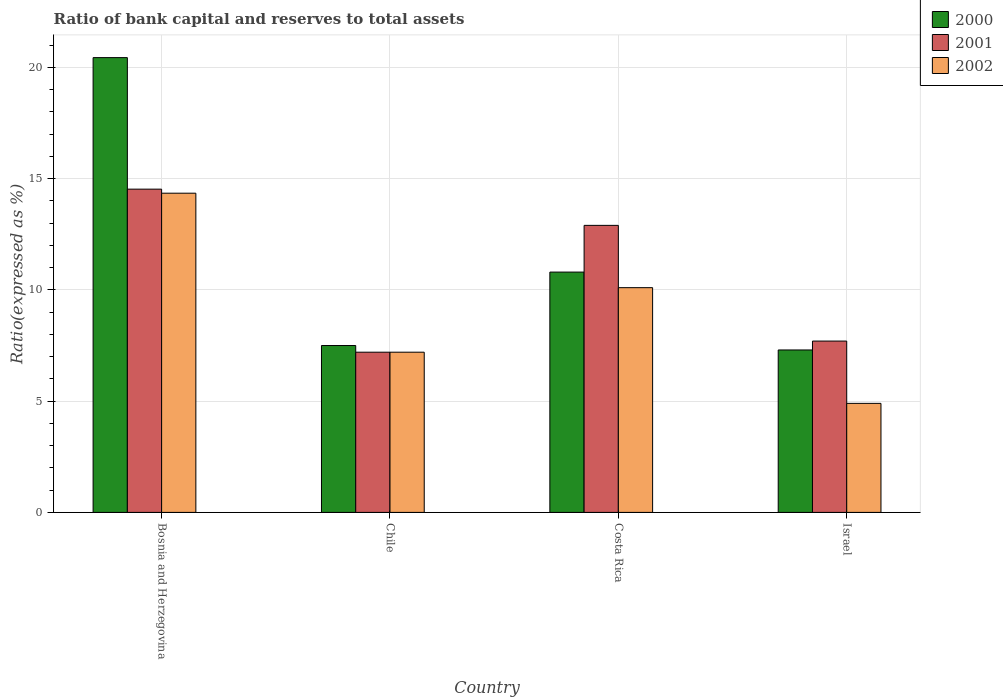How many groups of bars are there?
Offer a very short reply. 4. Are the number of bars per tick equal to the number of legend labels?
Give a very brief answer. Yes. Are the number of bars on each tick of the X-axis equal?
Make the answer very short. Yes. How many bars are there on the 1st tick from the left?
Ensure brevity in your answer.  3. How many bars are there on the 4th tick from the right?
Make the answer very short. 3. What is the label of the 4th group of bars from the left?
Offer a terse response. Israel. Across all countries, what is the maximum ratio of bank capital and reserves to total assets in 2001?
Provide a short and direct response. 14.53. In which country was the ratio of bank capital and reserves to total assets in 2000 maximum?
Your response must be concise. Bosnia and Herzegovina. In which country was the ratio of bank capital and reserves to total assets in 2001 minimum?
Ensure brevity in your answer.  Chile. What is the total ratio of bank capital and reserves to total assets in 2001 in the graph?
Your answer should be compact. 42.33. What is the difference between the ratio of bank capital and reserves to total assets in 2002 in Chile and that in Costa Rica?
Your response must be concise. -2.9. What is the difference between the ratio of bank capital and reserves to total assets in 2000 in Bosnia and Herzegovina and the ratio of bank capital and reserves to total assets in 2001 in Israel?
Give a very brief answer. 12.74. What is the average ratio of bank capital and reserves to total assets in 2000 per country?
Your answer should be compact. 11.51. What is the difference between the ratio of bank capital and reserves to total assets of/in 2002 and ratio of bank capital and reserves to total assets of/in 2001 in Bosnia and Herzegovina?
Your answer should be very brief. -0.18. What is the ratio of the ratio of bank capital and reserves to total assets in 2002 in Bosnia and Herzegovina to that in Israel?
Give a very brief answer. 2.93. Is the ratio of bank capital and reserves to total assets in 2001 in Bosnia and Herzegovina less than that in Costa Rica?
Provide a succinct answer. No. What is the difference between the highest and the second highest ratio of bank capital and reserves to total assets in 2001?
Your answer should be very brief. -1.63. What is the difference between the highest and the lowest ratio of bank capital and reserves to total assets in 2000?
Give a very brief answer. 13.14. What does the 2nd bar from the left in Israel represents?
Keep it short and to the point. 2001. Is it the case that in every country, the sum of the ratio of bank capital and reserves to total assets in 2002 and ratio of bank capital and reserves to total assets in 2000 is greater than the ratio of bank capital and reserves to total assets in 2001?
Offer a terse response. Yes. How many bars are there?
Provide a succinct answer. 12. Are all the bars in the graph horizontal?
Offer a very short reply. No. What is the title of the graph?
Offer a very short reply. Ratio of bank capital and reserves to total assets. What is the label or title of the Y-axis?
Provide a succinct answer. Ratio(expressed as %). What is the Ratio(expressed as %) in 2000 in Bosnia and Herzegovina?
Keep it short and to the point. 20.44. What is the Ratio(expressed as %) of 2001 in Bosnia and Herzegovina?
Your answer should be very brief. 14.53. What is the Ratio(expressed as %) in 2002 in Bosnia and Herzegovina?
Your answer should be very brief. 14.35. What is the Ratio(expressed as %) of 2000 in Chile?
Make the answer very short. 7.5. What is the Ratio(expressed as %) in 2002 in Chile?
Your response must be concise. 7.2. What is the Ratio(expressed as %) of 2000 in Israel?
Offer a very short reply. 7.3. Across all countries, what is the maximum Ratio(expressed as %) in 2000?
Your response must be concise. 20.44. Across all countries, what is the maximum Ratio(expressed as %) of 2001?
Make the answer very short. 14.53. Across all countries, what is the maximum Ratio(expressed as %) in 2002?
Ensure brevity in your answer.  14.35. Across all countries, what is the minimum Ratio(expressed as %) in 2000?
Your answer should be very brief. 7.3. Across all countries, what is the minimum Ratio(expressed as %) of 2001?
Your answer should be compact. 7.2. What is the total Ratio(expressed as %) in 2000 in the graph?
Your answer should be compact. 46.04. What is the total Ratio(expressed as %) in 2001 in the graph?
Provide a short and direct response. 42.33. What is the total Ratio(expressed as %) in 2002 in the graph?
Ensure brevity in your answer.  36.55. What is the difference between the Ratio(expressed as %) in 2000 in Bosnia and Herzegovina and that in Chile?
Keep it short and to the point. 12.94. What is the difference between the Ratio(expressed as %) of 2001 in Bosnia and Herzegovina and that in Chile?
Your answer should be very brief. 7.33. What is the difference between the Ratio(expressed as %) of 2002 in Bosnia and Herzegovina and that in Chile?
Provide a short and direct response. 7.15. What is the difference between the Ratio(expressed as %) of 2000 in Bosnia and Herzegovina and that in Costa Rica?
Ensure brevity in your answer.  9.64. What is the difference between the Ratio(expressed as %) of 2001 in Bosnia and Herzegovina and that in Costa Rica?
Make the answer very short. 1.63. What is the difference between the Ratio(expressed as %) of 2002 in Bosnia and Herzegovina and that in Costa Rica?
Your answer should be very brief. 4.25. What is the difference between the Ratio(expressed as %) of 2000 in Bosnia and Herzegovina and that in Israel?
Give a very brief answer. 13.14. What is the difference between the Ratio(expressed as %) of 2001 in Bosnia and Herzegovina and that in Israel?
Provide a succinct answer. 6.83. What is the difference between the Ratio(expressed as %) of 2002 in Bosnia and Herzegovina and that in Israel?
Offer a very short reply. 9.45. What is the difference between the Ratio(expressed as %) in 2000 in Chile and that in Costa Rica?
Your answer should be very brief. -3.3. What is the difference between the Ratio(expressed as %) of 2001 in Chile and that in Costa Rica?
Offer a very short reply. -5.7. What is the difference between the Ratio(expressed as %) in 2000 in Chile and that in Israel?
Offer a terse response. 0.2. What is the difference between the Ratio(expressed as %) in 2001 in Chile and that in Israel?
Offer a very short reply. -0.5. What is the difference between the Ratio(expressed as %) in 2001 in Costa Rica and that in Israel?
Provide a succinct answer. 5.2. What is the difference between the Ratio(expressed as %) of 2002 in Costa Rica and that in Israel?
Give a very brief answer. 5.2. What is the difference between the Ratio(expressed as %) of 2000 in Bosnia and Herzegovina and the Ratio(expressed as %) of 2001 in Chile?
Offer a terse response. 13.24. What is the difference between the Ratio(expressed as %) of 2000 in Bosnia and Herzegovina and the Ratio(expressed as %) of 2002 in Chile?
Offer a very short reply. 13.24. What is the difference between the Ratio(expressed as %) of 2001 in Bosnia and Herzegovina and the Ratio(expressed as %) of 2002 in Chile?
Give a very brief answer. 7.33. What is the difference between the Ratio(expressed as %) of 2000 in Bosnia and Herzegovina and the Ratio(expressed as %) of 2001 in Costa Rica?
Offer a terse response. 7.54. What is the difference between the Ratio(expressed as %) in 2000 in Bosnia and Herzegovina and the Ratio(expressed as %) in 2002 in Costa Rica?
Give a very brief answer. 10.34. What is the difference between the Ratio(expressed as %) in 2001 in Bosnia and Herzegovina and the Ratio(expressed as %) in 2002 in Costa Rica?
Ensure brevity in your answer.  4.43. What is the difference between the Ratio(expressed as %) in 2000 in Bosnia and Herzegovina and the Ratio(expressed as %) in 2001 in Israel?
Give a very brief answer. 12.74. What is the difference between the Ratio(expressed as %) of 2000 in Bosnia and Herzegovina and the Ratio(expressed as %) of 2002 in Israel?
Offer a very short reply. 15.54. What is the difference between the Ratio(expressed as %) in 2001 in Bosnia and Herzegovina and the Ratio(expressed as %) in 2002 in Israel?
Keep it short and to the point. 9.63. What is the difference between the Ratio(expressed as %) in 2000 in Chile and the Ratio(expressed as %) in 2001 in Israel?
Provide a short and direct response. -0.2. What is the difference between the Ratio(expressed as %) of 2001 in Chile and the Ratio(expressed as %) of 2002 in Israel?
Provide a succinct answer. 2.3. What is the average Ratio(expressed as %) in 2000 per country?
Keep it short and to the point. 11.51. What is the average Ratio(expressed as %) in 2001 per country?
Provide a short and direct response. 10.58. What is the average Ratio(expressed as %) in 2002 per country?
Provide a succinct answer. 9.14. What is the difference between the Ratio(expressed as %) of 2000 and Ratio(expressed as %) of 2001 in Bosnia and Herzegovina?
Give a very brief answer. 5.91. What is the difference between the Ratio(expressed as %) in 2000 and Ratio(expressed as %) in 2002 in Bosnia and Herzegovina?
Provide a short and direct response. 6.09. What is the difference between the Ratio(expressed as %) of 2001 and Ratio(expressed as %) of 2002 in Bosnia and Herzegovina?
Your response must be concise. 0.18. What is the difference between the Ratio(expressed as %) of 2000 and Ratio(expressed as %) of 2001 in Costa Rica?
Your answer should be very brief. -2.1. What is the difference between the Ratio(expressed as %) in 2000 and Ratio(expressed as %) in 2002 in Costa Rica?
Your answer should be compact. 0.7. What is the difference between the Ratio(expressed as %) in 2001 and Ratio(expressed as %) in 2002 in Costa Rica?
Make the answer very short. 2.8. What is the ratio of the Ratio(expressed as %) in 2000 in Bosnia and Herzegovina to that in Chile?
Your response must be concise. 2.73. What is the ratio of the Ratio(expressed as %) in 2001 in Bosnia and Herzegovina to that in Chile?
Provide a succinct answer. 2.02. What is the ratio of the Ratio(expressed as %) in 2002 in Bosnia and Herzegovina to that in Chile?
Keep it short and to the point. 1.99. What is the ratio of the Ratio(expressed as %) in 2000 in Bosnia and Herzegovina to that in Costa Rica?
Your answer should be compact. 1.89. What is the ratio of the Ratio(expressed as %) of 2001 in Bosnia and Herzegovina to that in Costa Rica?
Provide a succinct answer. 1.13. What is the ratio of the Ratio(expressed as %) in 2002 in Bosnia and Herzegovina to that in Costa Rica?
Provide a succinct answer. 1.42. What is the ratio of the Ratio(expressed as %) in 2000 in Bosnia and Herzegovina to that in Israel?
Your answer should be very brief. 2.8. What is the ratio of the Ratio(expressed as %) in 2001 in Bosnia and Herzegovina to that in Israel?
Offer a terse response. 1.89. What is the ratio of the Ratio(expressed as %) in 2002 in Bosnia and Herzegovina to that in Israel?
Offer a very short reply. 2.93. What is the ratio of the Ratio(expressed as %) of 2000 in Chile to that in Costa Rica?
Provide a succinct answer. 0.69. What is the ratio of the Ratio(expressed as %) of 2001 in Chile to that in Costa Rica?
Provide a short and direct response. 0.56. What is the ratio of the Ratio(expressed as %) of 2002 in Chile to that in Costa Rica?
Your response must be concise. 0.71. What is the ratio of the Ratio(expressed as %) in 2000 in Chile to that in Israel?
Give a very brief answer. 1.03. What is the ratio of the Ratio(expressed as %) in 2001 in Chile to that in Israel?
Offer a terse response. 0.94. What is the ratio of the Ratio(expressed as %) of 2002 in Chile to that in Israel?
Ensure brevity in your answer.  1.47. What is the ratio of the Ratio(expressed as %) of 2000 in Costa Rica to that in Israel?
Offer a very short reply. 1.48. What is the ratio of the Ratio(expressed as %) of 2001 in Costa Rica to that in Israel?
Ensure brevity in your answer.  1.68. What is the ratio of the Ratio(expressed as %) of 2002 in Costa Rica to that in Israel?
Provide a short and direct response. 2.06. What is the difference between the highest and the second highest Ratio(expressed as %) in 2000?
Ensure brevity in your answer.  9.64. What is the difference between the highest and the second highest Ratio(expressed as %) in 2001?
Your response must be concise. 1.63. What is the difference between the highest and the second highest Ratio(expressed as %) of 2002?
Provide a succinct answer. 4.25. What is the difference between the highest and the lowest Ratio(expressed as %) in 2000?
Offer a very short reply. 13.14. What is the difference between the highest and the lowest Ratio(expressed as %) in 2001?
Ensure brevity in your answer.  7.33. What is the difference between the highest and the lowest Ratio(expressed as %) in 2002?
Provide a short and direct response. 9.45. 